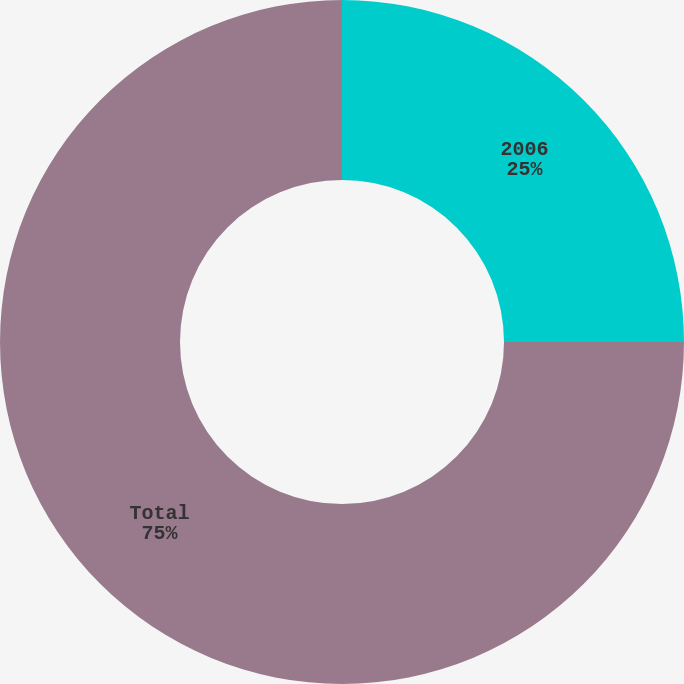Convert chart to OTSL. <chart><loc_0><loc_0><loc_500><loc_500><pie_chart><fcel>2006<fcel>Total<nl><fcel>25.0%<fcel>75.0%<nl></chart> 